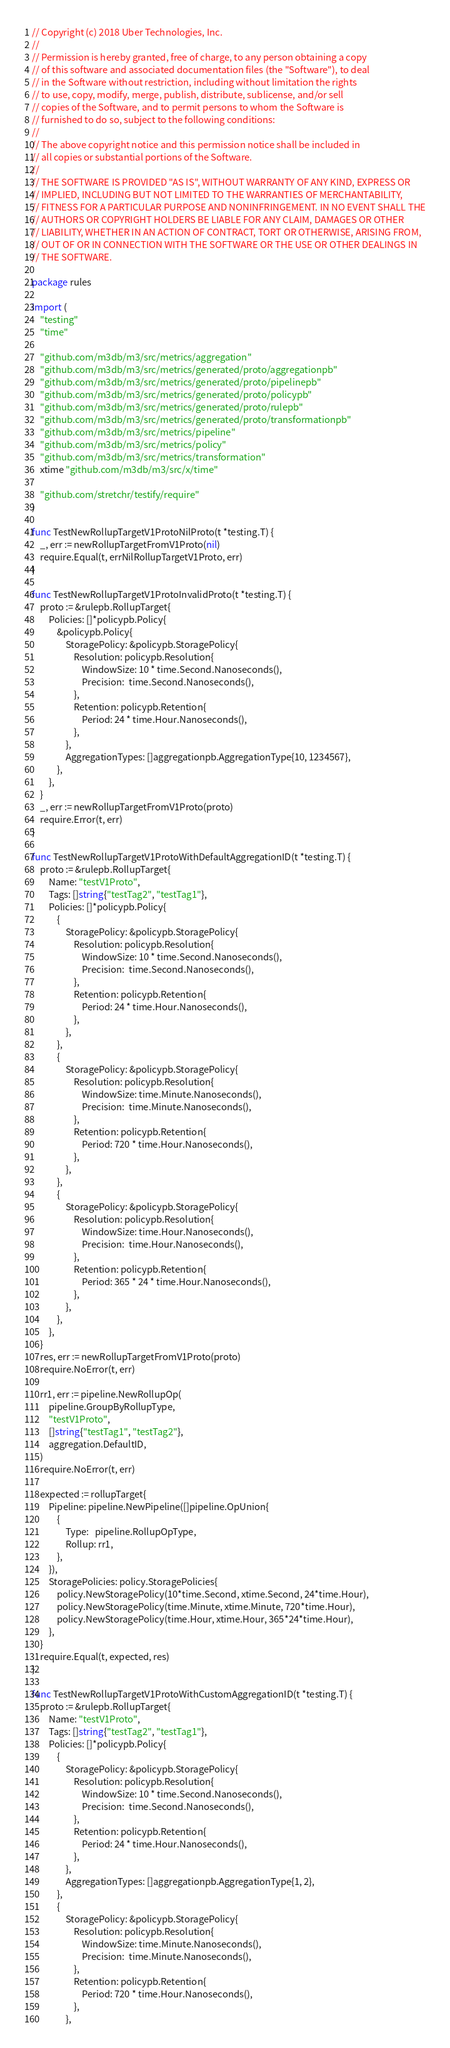Convert code to text. <code><loc_0><loc_0><loc_500><loc_500><_Go_>// Copyright (c) 2018 Uber Technologies, Inc.
//
// Permission is hereby granted, free of charge, to any person obtaining a copy
// of this software and associated documentation files (the "Software"), to deal
// in the Software without restriction, including without limitation the rights
// to use, copy, modify, merge, publish, distribute, sublicense, and/or sell
// copies of the Software, and to permit persons to whom the Software is
// furnished to do so, subject to the following conditions:
//
// The above copyright notice and this permission notice shall be included in
// all copies or substantial portions of the Software.
//
// THE SOFTWARE IS PROVIDED "AS IS", WITHOUT WARRANTY OF ANY KIND, EXPRESS OR
// IMPLIED, INCLUDING BUT NOT LIMITED TO THE WARRANTIES OF MERCHANTABILITY,
// FITNESS FOR A PARTICULAR PURPOSE AND NONINFRINGEMENT. IN NO EVENT SHALL THE
// AUTHORS OR COPYRIGHT HOLDERS BE LIABLE FOR ANY CLAIM, DAMAGES OR OTHER
// LIABILITY, WHETHER IN AN ACTION OF CONTRACT, TORT OR OTHERWISE, ARISING FROM,
// OUT OF OR IN CONNECTION WITH THE SOFTWARE OR THE USE OR OTHER DEALINGS IN
// THE SOFTWARE.

package rules

import (
	"testing"
	"time"

	"github.com/m3db/m3/src/metrics/aggregation"
	"github.com/m3db/m3/src/metrics/generated/proto/aggregationpb"
	"github.com/m3db/m3/src/metrics/generated/proto/pipelinepb"
	"github.com/m3db/m3/src/metrics/generated/proto/policypb"
	"github.com/m3db/m3/src/metrics/generated/proto/rulepb"
	"github.com/m3db/m3/src/metrics/generated/proto/transformationpb"
	"github.com/m3db/m3/src/metrics/pipeline"
	"github.com/m3db/m3/src/metrics/policy"
	"github.com/m3db/m3/src/metrics/transformation"
	xtime "github.com/m3db/m3/src/x/time"

	"github.com/stretchr/testify/require"
)

func TestNewRollupTargetV1ProtoNilProto(t *testing.T) {
	_, err := newRollupTargetFromV1Proto(nil)
	require.Equal(t, errNilRollupTargetV1Proto, err)
}

func TestNewRollupTargetV1ProtoInvalidProto(t *testing.T) {
	proto := &rulepb.RollupTarget{
		Policies: []*policypb.Policy{
			&policypb.Policy{
				StoragePolicy: &policypb.StoragePolicy{
					Resolution: policypb.Resolution{
						WindowSize: 10 * time.Second.Nanoseconds(),
						Precision:  time.Second.Nanoseconds(),
					},
					Retention: policypb.Retention{
						Period: 24 * time.Hour.Nanoseconds(),
					},
				},
				AggregationTypes: []aggregationpb.AggregationType{10, 1234567},
			},
		},
	}
	_, err := newRollupTargetFromV1Proto(proto)
	require.Error(t, err)
}

func TestNewRollupTargetV1ProtoWithDefaultAggregationID(t *testing.T) {
	proto := &rulepb.RollupTarget{
		Name: "testV1Proto",
		Tags: []string{"testTag2", "testTag1"},
		Policies: []*policypb.Policy{
			{
				StoragePolicy: &policypb.StoragePolicy{
					Resolution: policypb.Resolution{
						WindowSize: 10 * time.Second.Nanoseconds(),
						Precision:  time.Second.Nanoseconds(),
					},
					Retention: policypb.Retention{
						Period: 24 * time.Hour.Nanoseconds(),
					},
				},
			},
			{
				StoragePolicy: &policypb.StoragePolicy{
					Resolution: policypb.Resolution{
						WindowSize: time.Minute.Nanoseconds(),
						Precision:  time.Minute.Nanoseconds(),
					},
					Retention: policypb.Retention{
						Period: 720 * time.Hour.Nanoseconds(),
					},
				},
			},
			{
				StoragePolicy: &policypb.StoragePolicy{
					Resolution: policypb.Resolution{
						WindowSize: time.Hour.Nanoseconds(),
						Precision:  time.Hour.Nanoseconds(),
					},
					Retention: policypb.Retention{
						Period: 365 * 24 * time.Hour.Nanoseconds(),
					},
				},
			},
		},
	}
	res, err := newRollupTargetFromV1Proto(proto)
	require.NoError(t, err)

	rr1, err := pipeline.NewRollupOp(
		pipeline.GroupByRollupType,
		"testV1Proto",
		[]string{"testTag1", "testTag2"},
		aggregation.DefaultID,
	)
	require.NoError(t, err)

	expected := rollupTarget{
		Pipeline: pipeline.NewPipeline([]pipeline.OpUnion{
			{
				Type:   pipeline.RollupOpType,
				Rollup: rr1,
			},
		}),
		StoragePolicies: policy.StoragePolicies{
			policy.NewStoragePolicy(10*time.Second, xtime.Second, 24*time.Hour),
			policy.NewStoragePolicy(time.Minute, xtime.Minute, 720*time.Hour),
			policy.NewStoragePolicy(time.Hour, xtime.Hour, 365*24*time.Hour),
		},
	}
	require.Equal(t, expected, res)
}

func TestNewRollupTargetV1ProtoWithCustomAggregationID(t *testing.T) {
	proto := &rulepb.RollupTarget{
		Name: "testV1Proto",
		Tags: []string{"testTag2", "testTag1"},
		Policies: []*policypb.Policy{
			{
				StoragePolicy: &policypb.StoragePolicy{
					Resolution: policypb.Resolution{
						WindowSize: 10 * time.Second.Nanoseconds(),
						Precision:  time.Second.Nanoseconds(),
					},
					Retention: policypb.Retention{
						Period: 24 * time.Hour.Nanoseconds(),
					},
				},
				AggregationTypes: []aggregationpb.AggregationType{1, 2},
			},
			{
				StoragePolicy: &policypb.StoragePolicy{
					Resolution: policypb.Resolution{
						WindowSize: time.Minute.Nanoseconds(),
						Precision:  time.Minute.Nanoseconds(),
					},
					Retention: policypb.Retention{
						Period: 720 * time.Hour.Nanoseconds(),
					},
				},</code> 